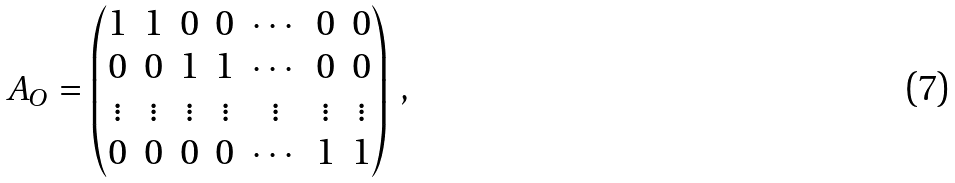Convert formula to latex. <formula><loc_0><loc_0><loc_500><loc_500>A _ { O } = \begin{pmatrix} 1 & 1 & 0 & 0 & \cdots & 0 & 0 \\ 0 & 0 & 1 & 1 & \cdots & 0 & 0 \\ \vdots & \vdots & \vdots & \vdots & \vdots & \vdots & \vdots \\ 0 & 0 & 0 & 0 & \cdots & 1 & 1 \\ \end{pmatrix} \, ,</formula> 